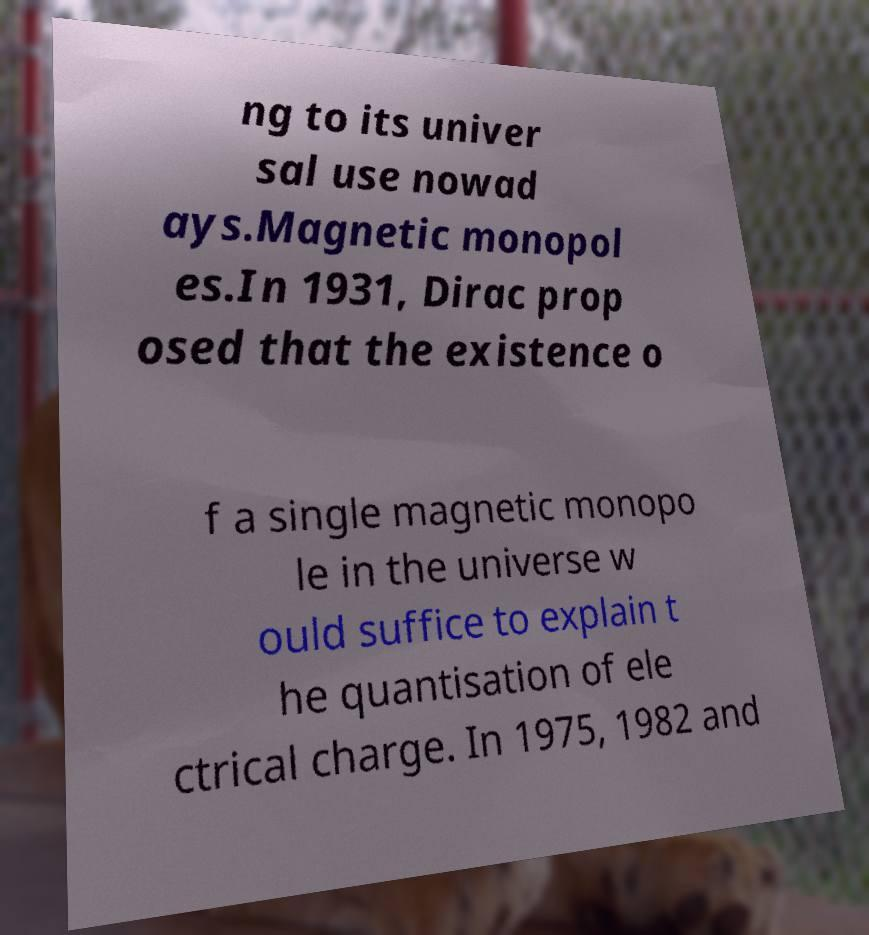I need the written content from this picture converted into text. Can you do that? ng to its univer sal use nowad ays.Magnetic monopol es.In 1931, Dirac prop osed that the existence o f a single magnetic monopo le in the universe w ould suffice to explain t he quantisation of ele ctrical charge. In 1975, 1982 and 